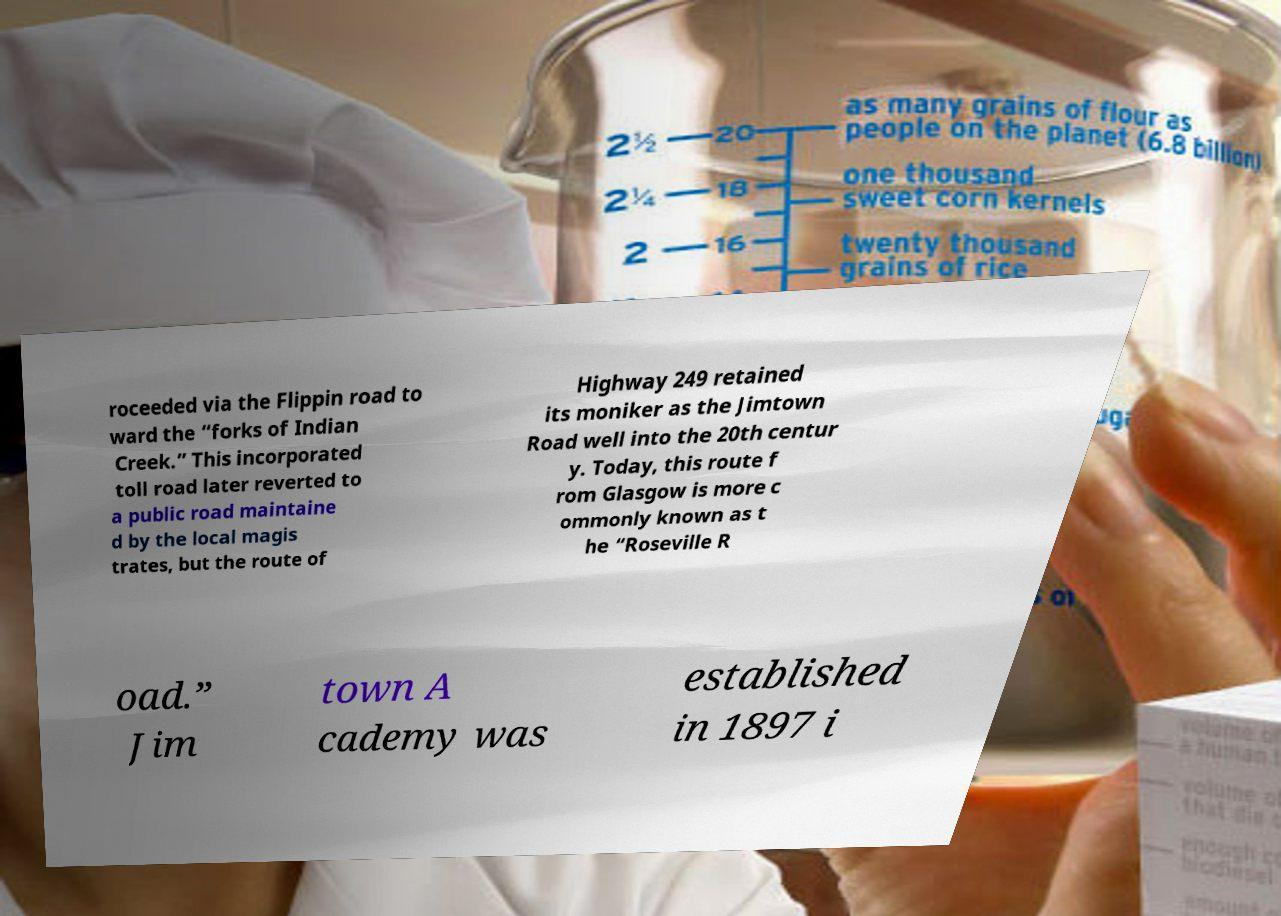I need the written content from this picture converted into text. Can you do that? roceeded via the Flippin road to ward the “forks of Indian Creek.” This incorporated toll road later reverted to a public road maintaine d by the local magis trates, but the route of Highway 249 retained its moniker as the Jimtown Road well into the 20th centur y. Today, this route f rom Glasgow is more c ommonly known as t he “Roseville R oad.” Jim town A cademy was established in 1897 i 